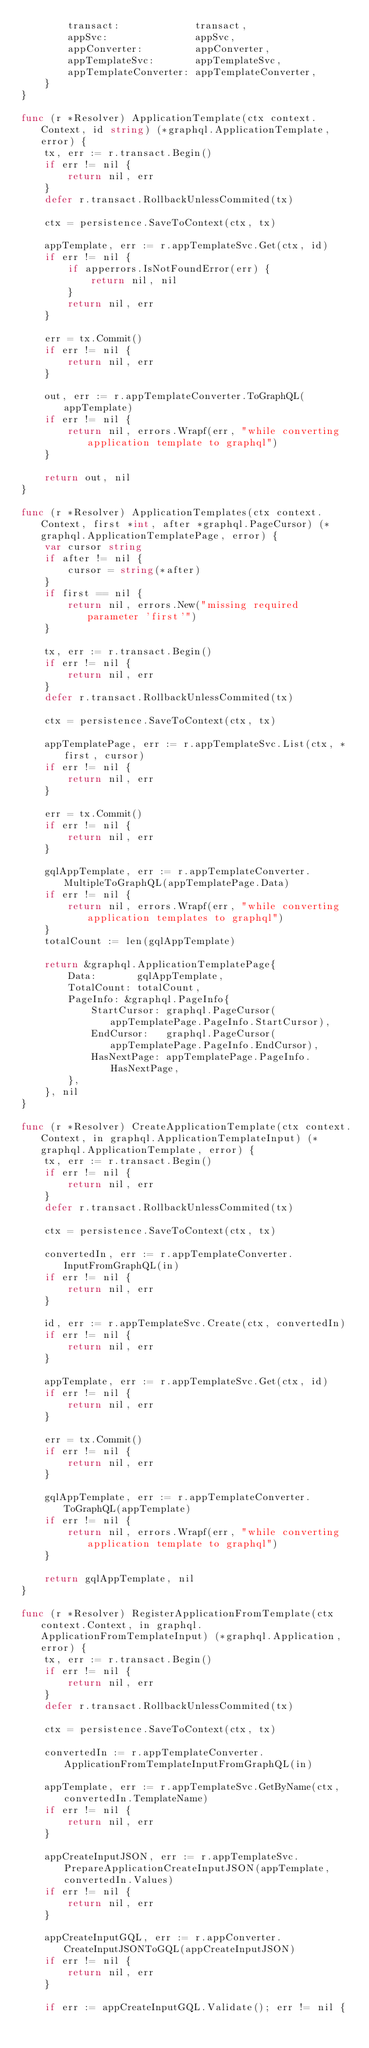Convert code to text. <code><loc_0><loc_0><loc_500><loc_500><_Go_>		transact:             transact,
		appSvc:               appSvc,
		appConverter:         appConverter,
		appTemplateSvc:       appTemplateSvc,
		appTemplateConverter: appTemplateConverter,
	}
}

func (r *Resolver) ApplicationTemplate(ctx context.Context, id string) (*graphql.ApplicationTemplate, error) {
	tx, err := r.transact.Begin()
	if err != nil {
		return nil, err
	}
	defer r.transact.RollbackUnlessCommited(tx)

	ctx = persistence.SaveToContext(ctx, tx)

	appTemplate, err := r.appTemplateSvc.Get(ctx, id)
	if err != nil {
		if apperrors.IsNotFoundError(err) {
			return nil, nil
		}
		return nil, err
	}

	err = tx.Commit()
	if err != nil {
		return nil, err
	}

	out, err := r.appTemplateConverter.ToGraphQL(appTemplate)
	if err != nil {
		return nil, errors.Wrapf(err, "while converting application template to graphql")
	}

	return out, nil
}

func (r *Resolver) ApplicationTemplates(ctx context.Context, first *int, after *graphql.PageCursor) (*graphql.ApplicationTemplatePage, error) {
	var cursor string
	if after != nil {
		cursor = string(*after)
	}
	if first == nil {
		return nil, errors.New("missing required parameter 'first'")
	}

	tx, err := r.transact.Begin()
	if err != nil {
		return nil, err
	}
	defer r.transact.RollbackUnlessCommited(tx)

	ctx = persistence.SaveToContext(ctx, tx)

	appTemplatePage, err := r.appTemplateSvc.List(ctx, *first, cursor)
	if err != nil {
		return nil, err
	}

	err = tx.Commit()
	if err != nil {
		return nil, err
	}

	gqlAppTemplate, err := r.appTemplateConverter.MultipleToGraphQL(appTemplatePage.Data)
	if err != nil {
		return nil, errors.Wrapf(err, "while converting application templates to graphql")
	}
	totalCount := len(gqlAppTemplate)

	return &graphql.ApplicationTemplatePage{
		Data:       gqlAppTemplate,
		TotalCount: totalCount,
		PageInfo: &graphql.PageInfo{
			StartCursor: graphql.PageCursor(appTemplatePage.PageInfo.StartCursor),
			EndCursor:   graphql.PageCursor(appTemplatePage.PageInfo.EndCursor),
			HasNextPage: appTemplatePage.PageInfo.HasNextPage,
		},
	}, nil
}

func (r *Resolver) CreateApplicationTemplate(ctx context.Context, in graphql.ApplicationTemplateInput) (*graphql.ApplicationTemplate, error) {
	tx, err := r.transact.Begin()
	if err != nil {
		return nil, err
	}
	defer r.transact.RollbackUnlessCommited(tx)

	ctx = persistence.SaveToContext(ctx, tx)

	convertedIn, err := r.appTemplateConverter.InputFromGraphQL(in)
	if err != nil {
		return nil, err
	}

	id, err := r.appTemplateSvc.Create(ctx, convertedIn)
	if err != nil {
		return nil, err
	}

	appTemplate, err := r.appTemplateSvc.Get(ctx, id)
	if err != nil {
		return nil, err
	}

	err = tx.Commit()
	if err != nil {
		return nil, err
	}

	gqlAppTemplate, err := r.appTemplateConverter.ToGraphQL(appTemplate)
	if err != nil {
		return nil, errors.Wrapf(err, "while converting application template to graphql")
	}

	return gqlAppTemplate, nil
}

func (r *Resolver) RegisterApplicationFromTemplate(ctx context.Context, in graphql.ApplicationFromTemplateInput) (*graphql.Application, error) {
	tx, err := r.transact.Begin()
	if err != nil {
		return nil, err
	}
	defer r.transact.RollbackUnlessCommited(tx)

	ctx = persistence.SaveToContext(ctx, tx)

	convertedIn := r.appTemplateConverter.ApplicationFromTemplateInputFromGraphQL(in)

	appTemplate, err := r.appTemplateSvc.GetByName(ctx, convertedIn.TemplateName)
	if err != nil {
		return nil, err
	}

	appCreateInputJSON, err := r.appTemplateSvc.PrepareApplicationCreateInputJSON(appTemplate, convertedIn.Values)
	if err != nil {
		return nil, err
	}

	appCreateInputGQL, err := r.appConverter.CreateInputJSONToGQL(appCreateInputJSON)
	if err != nil {
		return nil, err
	}

	if err := appCreateInputGQL.Validate(); err != nil {</code> 